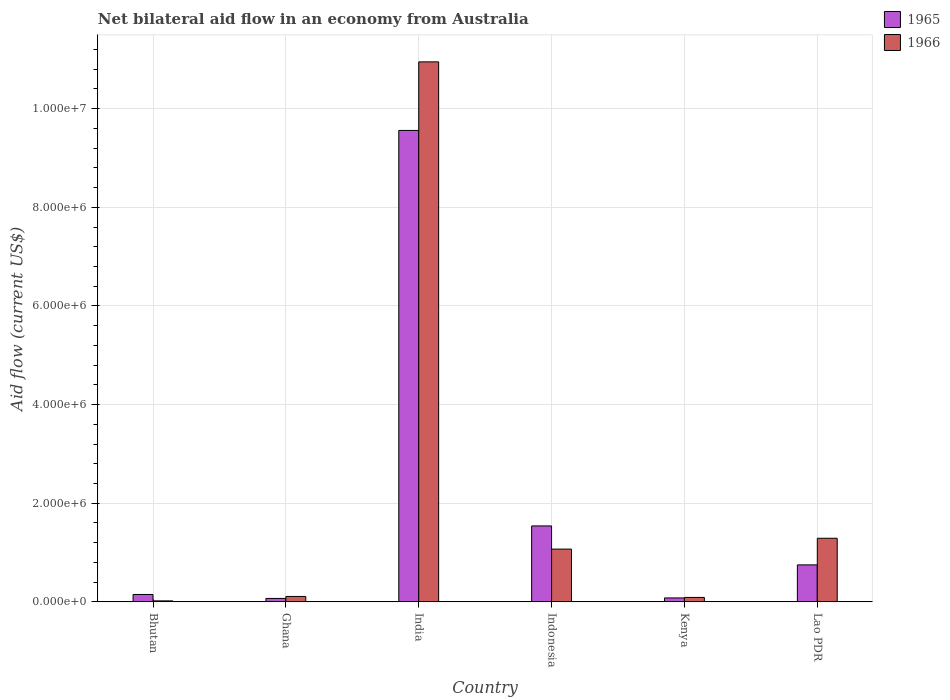How many groups of bars are there?
Ensure brevity in your answer.  6. Are the number of bars per tick equal to the number of legend labels?
Your answer should be compact. Yes. Are the number of bars on each tick of the X-axis equal?
Offer a terse response. Yes. How many bars are there on the 3rd tick from the right?
Offer a terse response. 2. What is the label of the 1st group of bars from the left?
Offer a terse response. Bhutan. In how many cases, is the number of bars for a given country not equal to the number of legend labels?
Ensure brevity in your answer.  0. Across all countries, what is the maximum net bilateral aid flow in 1965?
Provide a short and direct response. 9.56e+06. In which country was the net bilateral aid flow in 1966 minimum?
Make the answer very short. Bhutan. What is the total net bilateral aid flow in 1966 in the graph?
Your answer should be very brief. 1.35e+07. What is the difference between the net bilateral aid flow in 1966 in Indonesia and the net bilateral aid flow in 1965 in Kenya?
Your answer should be very brief. 9.90e+05. What is the average net bilateral aid flow in 1965 per country?
Provide a short and direct response. 2.02e+06. What is the difference between the net bilateral aid flow of/in 1966 and net bilateral aid flow of/in 1965 in India?
Give a very brief answer. 1.39e+06. In how many countries, is the net bilateral aid flow in 1966 greater than 3600000 US$?
Give a very brief answer. 1. What is the ratio of the net bilateral aid flow in 1965 in Ghana to that in Indonesia?
Your answer should be compact. 0.05. What is the difference between the highest and the second highest net bilateral aid flow in 1966?
Provide a succinct answer. 9.66e+06. What is the difference between the highest and the lowest net bilateral aid flow in 1966?
Offer a terse response. 1.09e+07. In how many countries, is the net bilateral aid flow in 1965 greater than the average net bilateral aid flow in 1965 taken over all countries?
Give a very brief answer. 1. What does the 2nd bar from the left in Lao PDR represents?
Your answer should be very brief. 1966. What does the 2nd bar from the right in Ghana represents?
Your answer should be very brief. 1965. Does the graph contain any zero values?
Give a very brief answer. No. Does the graph contain grids?
Provide a short and direct response. Yes. What is the title of the graph?
Offer a very short reply. Net bilateral aid flow in an economy from Australia. Does "1970" appear as one of the legend labels in the graph?
Offer a terse response. No. What is the label or title of the X-axis?
Your answer should be compact. Country. What is the label or title of the Y-axis?
Make the answer very short. Aid flow (current US$). What is the Aid flow (current US$) of 1965 in Bhutan?
Offer a very short reply. 1.50e+05. What is the Aid flow (current US$) in 1966 in Ghana?
Provide a short and direct response. 1.10e+05. What is the Aid flow (current US$) in 1965 in India?
Offer a terse response. 9.56e+06. What is the Aid flow (current US$) in 1966 in India?
Provide a short and direct response. 1.10e+07. What is the Aid flow (current US$) of 1965 in Indonesia?
Keep it short and to the point. 1.54e+06. What is the Aid flow (current US$) of 1966 in Indonesia?
Provide a short and direct response. 1.07e+06. What is the Aid flow (current US$) in 1966 in Kenya?
Keep it short and to the point. 9.00e+04. What is the Aid flow (current US$) of 1965 in Lao PDR?
Provide a succinct answer. 7.50e+05. What is the Aid flow (current US$) of 1966 in Lao PDR?
Offer a terse response. 1.29e+06. Across all countries, what is the maximum Aid flow (current US$) of 1965?
Your response must be concise. 9.56e+06. Across all countries, what is the maximum Aid flow (current US$) in 1966?
Offer a terse response. 1.10e+07. Across all countries, what is the minimum Aid flow (current US$) of 1965?
Give a very brief answer. 7.00e+04. What is the total Aid flow (current US$) in 1965 in the graph?
Keep it short and to the point. 1.22e+07. What is the total Aid flow (current US$) of 1966 in the graph?
Give a very brief answer. 1.35e+07. What is the difference between the Aid flow (current US$) of 1965 in Bhutan and that in India?
Your response must be concise. -9.41e+06. What is the difference between the Aid flow (current US$) of 1966 in Bhutan and that in India?
Offer a terse response. -1.09e+07. What is the difference between the Aid flow (current US$) in 1965 in Bhutan and that in Indonesia?
Offer a terse response. -1.39e+06. What is the difference between the Aid flow (current US$) of 1966 in Bhutan and that in Indonesia?
Provide a short and direct response. -1.05e+06. What is the difference between the Aid flow (current US$) of 1965 in Bhutan and that in Kenya?
Keep it short and to the point. 7.00e+04. What is the difference between the Aid flow (current US$) of 1966 in Bhutan and that in Kenya?
Offer a terse response. -7.00e+04. What is the difference between the Aid flow (current US$) of 1965 in Bhutan and that in Lao PDR?
Provide a short and direct response. -6.00e+05. What is the difference between the Aid flow (current US$) of 1966 in Bhutan and that in Lao PDR?
Your answer should be compact. -1.27e+06. What is the difference between the Aid flow (current US$) in 1965 in Ghana and that in India?
Your answer should be compact. -9.49e+06. What is the difference between the Aid flow (current US$) of 1966 in Ghana and that in India?
Ensure brevity in your answer.  -1.08e+07. What is the difference between the Aid flow (current US$) of 1965 in Ghana and that in Indonesia?
Your answer should be very brief. -1.47e+06. What is the difference between the Aid flow (current US$) of 1966 in Ghana and that in Indonesia?
Make the answer very short. -9.60e+05. What is the difference between the Aid flow (current US$) in 1966 in Ghana and that in Kenya?
Offer a terse response. 2.00e+04. What is the difference between the Aid flow (current US$) in 1965 in Ghana and that in Lao PDR?
Offer a terse response. -6.80e+05. What is the difference between the Aid flow (current US$) of 1966 in Ghana and that in Lao PDR?
Keep it short and to the point. -1.18e+06. What is the difference between the Aid flow (current US$) in 1965 in India and that in Indonesia?
Provide a short and direct response. 8.02e+06. What is the difference between the Aid flow (current US$) in 1966 in India and that in Indonesia?
Give a very brief answer. 9.88e+06. What is the difference between the Aid flow (current US$) of 1965 in India and that in Kenya?
Offer a terse response. 9.48e+06. What is the difference between the Aid flow (current US$) in 1966 in India and that in Kenya?
Give a very brief answer. 1.09e+07. What is the difference between the Aid flow (current US$) of 1965 in India and that in Lao PDR?
Provide a short and direct response. 8.81e+06. What is the difference between the Aid flow (current US$) in 1966 in India and that in Lao PDR?
Offer a terse response. 9.66e+06. What is the difference between the Aid flow (current US$) in 1965 in Indonesia and that in Kenya?
Your answer should be very brief. 1.46e+06. What is the difference between the Aid flow (current US$) of 1966 in Indonesia and that in Kenya?
Make the answer very short. 9.80e+05. What is the difference between the Aid flow (current US$) in 1965 in Indonesia and that in Lao PDR?
Ensure brevity in your answer.  7.90e+05. What is the difference between the Aid flow (current US$) of 1966 in Indonesia and that in Lao PDR?
Make the answer very short. -2.20e+05. What is the difference between the Aid flow (current US$) of 1965 in Kenya and that in Lao PDR?
Offer a terse response. -6.70e+05. What is the difference between the Aid flow (current US$) of 1966 in Kenya and that in Lao PDR?
Provide a short and direct response. -1.20e+06. What is the difference between the Aid flow (current US$) of 1965 in Bhutan and the Aid flow (current US$) of 1966 in Ghana?
Your answer should be very brief. 4.00e+04. What is the difference between the Aid flow (current US$) in 1965 in Bhutan and the Aid flow (current US$) in 1966 in India?
Your answer should be very brief. -1.08e+07. What is the difference between the Aid flow (current US$) in 1965 in Bhutan and the Aid flow (current US$) in 1966 in Indonesia?
Ensure brevity in your answer.  -9.20e+05. What is the difference between the Aid flow (current US$) in 1965 in Bhutan and the Aid flow (current US$) in 1966 in Kenya?
Make the answer very short. 6.00e+04. What is the difference between the Aid flow (current US$) in 1965 in Bhutan and the Aid flow (current US$) in 1966 in Lao PDR?
Provide a short and direct response. -1.14e+06. What is the difference between the Aid flow (current US$) in 1965 in Ghana and the Aid flow (current US$) in 1966 in India?
Provide a short and direct response. -1.09e+07. What is the difference between the Aid flow (current US$) of 1965 in Ghana and the Aid flow (current US$) of 1966 in Indonesia?
Give a very brief answer. -1.00e+06. What is the difference between the Aid flow (current US$) of 1965 in Ghana and the Aid flow (current US$) of 1966 in Lao PDR?
Give a very brief answer. -1.22e+06. What is the difference between the Aid flow (current US$) of 1965 in India and the Aid flow (current US$) of 1966 in Indonesia?
Give a very brief answer. 8.49e+06. What is the difference between the Aid flow (current US$) in 1965 in India and the Aid flow (current US$) in 1966 in Kenya?
Provide a succinct answer. 9.47e+06. What is the difference between the Aid flow (current US$) of 1965 in India and the Aid flow (current US$) of 1966 in Lao PDR?
Provide a short and direct response. 8.27e+06. What is the difference between the Aid flow (current US$) of 1965 in Indonesia and the Aid flow (current US$) of 1966 in Kenya?
Offer a very short reply. 1.45e+06. What is the difference between the Aid flow (current US$) in 1965 in Indonesia and the Aid flow (current US$) in 1966 in Lao PDR?
Your answer should be very brief. 2.50e+05. What is the difference between the Aid flow (current US$) of 1965 in Kenya and the Aid flow (current US$) of 1966 in Lao PDR?
Provide a succinct answer. -1.21e+06. What is the average Aid flow (current US$) in 1965 per country?
Your answer should be very brief. 2.02e+06. What is the average Aid flow (current US$) of 1966 per country?
Provide a succinct answer. 2.26e+06. What is the difference between the Aid flow (current US$) of 1965 and Aid flow (current US$) of 1966 in Bhutan?
Offer a terse response. 1.30e+05. What is the difference between the Aid flow (current US$) of 1965 and Aid flow (current US$) of 1966 in India?
Provide a succinct answer. -1.39e+06. What is the difference between the Aid flow (current US$) of 1965 and Aid flow (current US$) of 1966 in Indonesia?
Keep it short and to the point. 4.70e+05. What is the difference between the Aid flow (current US$) in 1965 and Aid flow (current US$) in 1966 in Kenya?
Offer a terse response. -10000. What is the difference between the Aid flow (current US$) in 1965 and Aid flow (current US$) in 1966 in Lao PDR?
Ensure brevity in your answer.  -5.40e+05. What is the ratio of the Aid flow (current US$) in 1965 in Bhutan to that in Ghana?
Your response must be concise. 2.14. What is the ratio of the Aid flow (current US$) of 1966 in Bhutan to that in Ghana?
Provide a short and direct response. 0.18. What is the ratio of the Aid flow (current US$) of 1965 in Bhutan to that in India?
Keep it short and to the point. 0.02. What is the ratio of the Aid flow (current US$) in 1966 in Bhutan to that in India?
Provide a short and direct response. 0. What is the ratio of the Aid flow (current US$) in 1965 in Bhutan to that in Indonesia?
Offer a very short reply. 0.1. What is the ratio of the Aid flow (current US$) of 1966 in Bhutan to that in Indonesia?
Your answer should be very brief. 0.02. What is the ratio of the Aid flow (current US$) in 1965 in Bhutan to that in Kenya?
Provide a short and direct response. 1.88. What is the ratio of the Aid flow (current US$) of 1966 in Bhutan to that in Kenya?
Your answer should be very brief. 0.22. What is the ratio of the Aid flow (current US$) in 1966 in Bhutan to that in Lao PDR?
Ensure brevity in your answer.  0.02. What is the ratio of the Aid flow (current US$) of 1965 in Ghana to that in India?
Keep it short and to the point. 0.01. What is the ratio of the Aid flow (current US$) of 1966 in Ghana to that in India?
Offer a terse response. 0.01. What is the ratio of the Aid flow (current US$) in 1965 in Ghana to that in Indonesia?
Offer a terse response. 0.05. What is the ratio of the Aid flow (current US$) in 1966 in Ghana to that in Indonesia?
Your answer should be very brief. 0.1. What is the ratio of the Aid flow (current US$) of 1965 in Ghana to that in Kenya?
Offer a very short reply. 0.88. What is the ratio of the Aid flow (current US$) of 1966 in Ghana to that in Kenya?
Provide a succinct answer. 1.22. What is the ratio of the Aid flow (current US$) of 1965 in Ghana to that in Lao PDR?
Offer a terse response. 0.09. What is the ratio of the Aid flow (current US$) of 1966 in Ghana to that in Lao PDR?
Provide a succinct answer. 0.09. What is the ratio of the Aid flow (current US$) in 1965 in India to that in Indonesia?
Give a very brief answer. 6.21. What is the ratio of the Aid flow (current US$) of 1966 in India to that in Indonesia?
Provide a short and direct response. 10.23. What is the ratio of the Aid flow (current US$) of 1965 in India to that in Kenya?
Provide a succinct answer. 119.5. What is the ratio of the Aid flow (current US$) of 1966 in India to that in Kenya?
Offer a very short reply. 121.67. What is the ratio of the Aid flow (current US$) in 1965 in India to that in Lao PDR?
Provide a succinct answer. 12.75. What is the ratio of the Aid flow (current US$) of 1966 in India to that in Lao PDR?
Provide a short and direct response. 8.49. What is the ratio of the Aid flow (current US$) in 1965 in Indonesia to that in Kenya?
Offer a terse response. 19.25. What is the ratio of the Aid flow (current US$) in 1966 in Indonesia to that in Kenya?
Provide a succinct answer. 11.89. What is the ratio of the Aid flow (current US$) in 1965 in Indonesia to that in Lao PDR?
Make the answer very short. 2.05. What is the ratio of the Aid flow (current US$) of 1966 in Indonesia to that in Lao PDR?
Make the answer very short. 0.83. What is the ratio of the Aid flow (current US$) of 1965 in Kenya to that in Lao PDR?
Make the answer very short. 0.11. What is the ratio of the Aid flow (current US$) of 1966 in Kenya to that in Lao PDR?
Your answer should be very brief. 0.07. What is the difference between the highest and the second highest Aid flow (current US$) in 1965?
Keep it short and to the point. 8.02e+06. What is the difference between the highest and the second highest Aid flow (current US$) of 1966?
Give a very brief answer. 9.66e+06. What is the difference between the highest and the lowest Aid flow (current US$) of 1965?
Make the answer very short. 9.49e+06. What is the difference between the highest and the lowest Aid flow (current US$) in 1966?
Your response must be concise. 1.09e+07. 